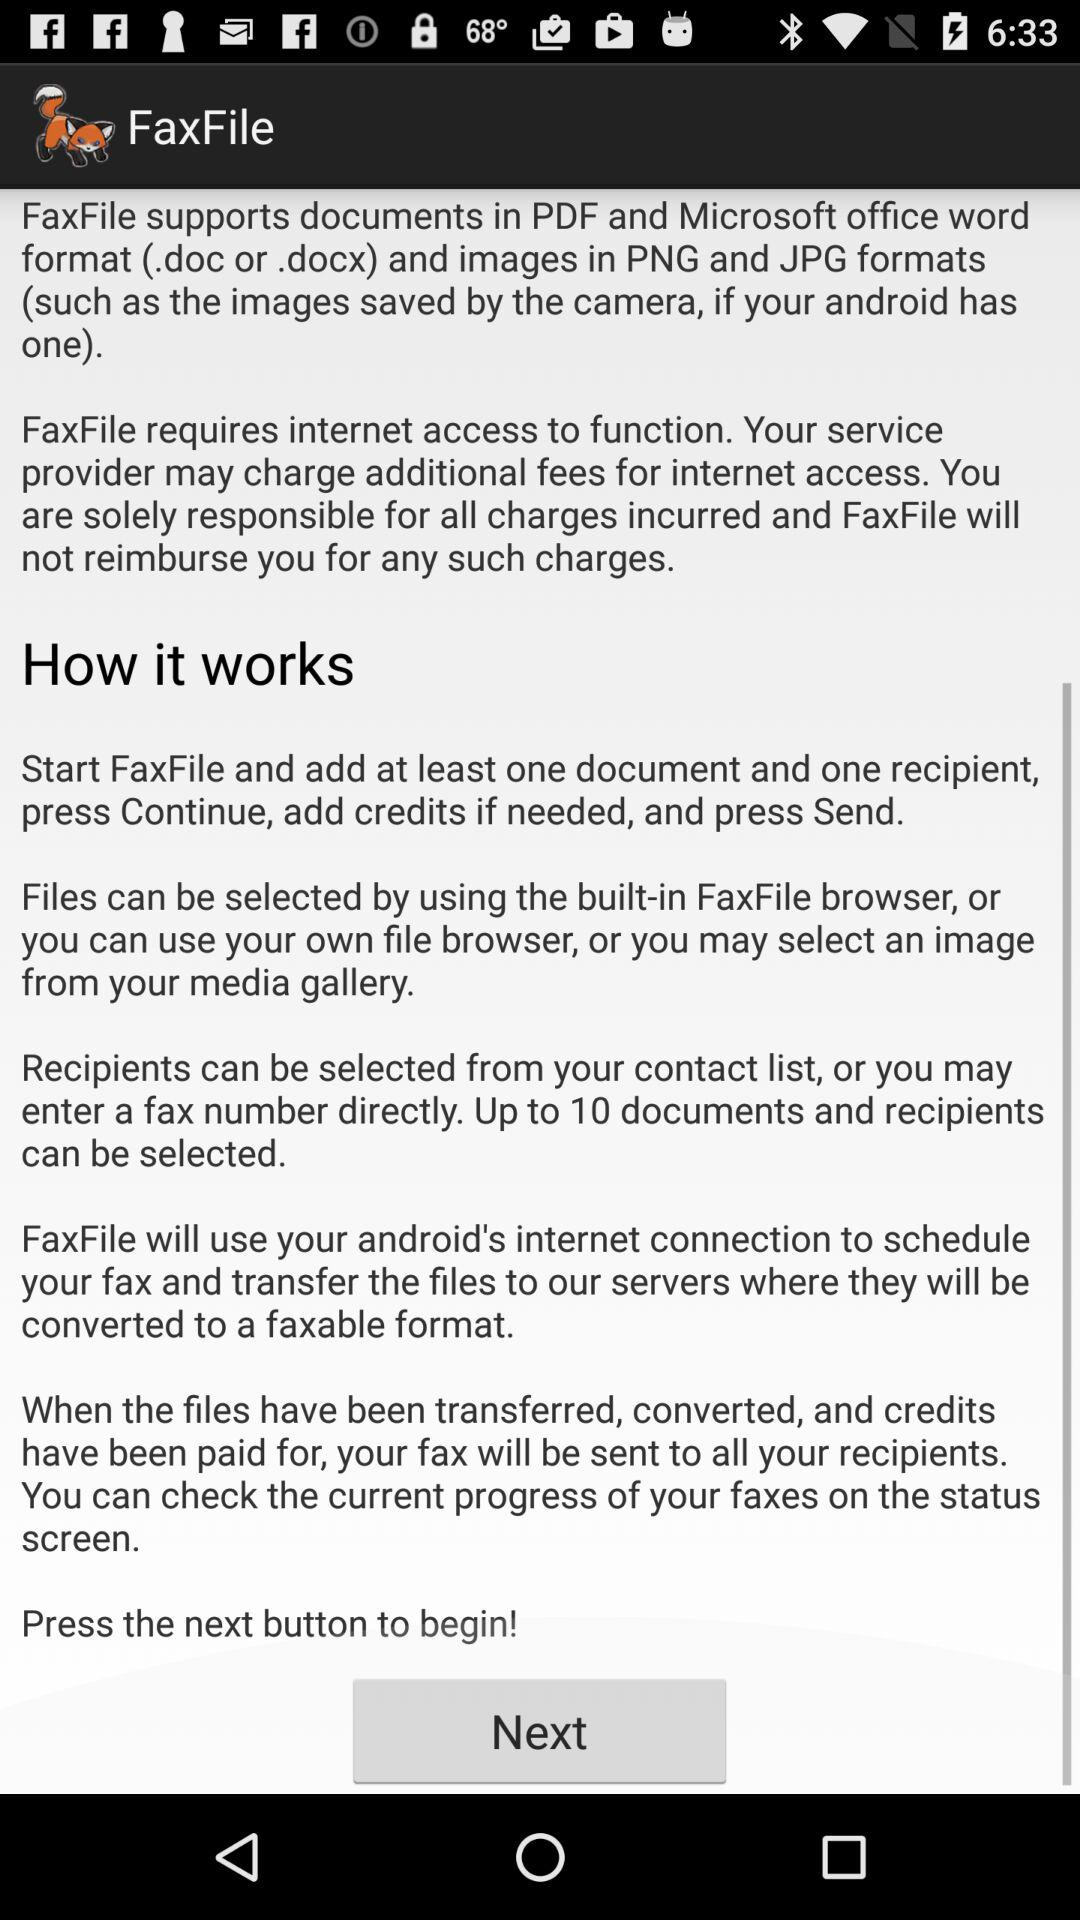How many documents can be selected?
Answer the question using a single word or phrase. Up to 10 